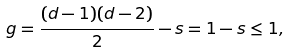Convert formula to latex. <formula><loc_0><loc_0><loc_500><loc_500>g = \frac { ( d - 1 ) ( d - 2 ) } { 2 } - s = 1 - s \leq 1 ,</formula> 